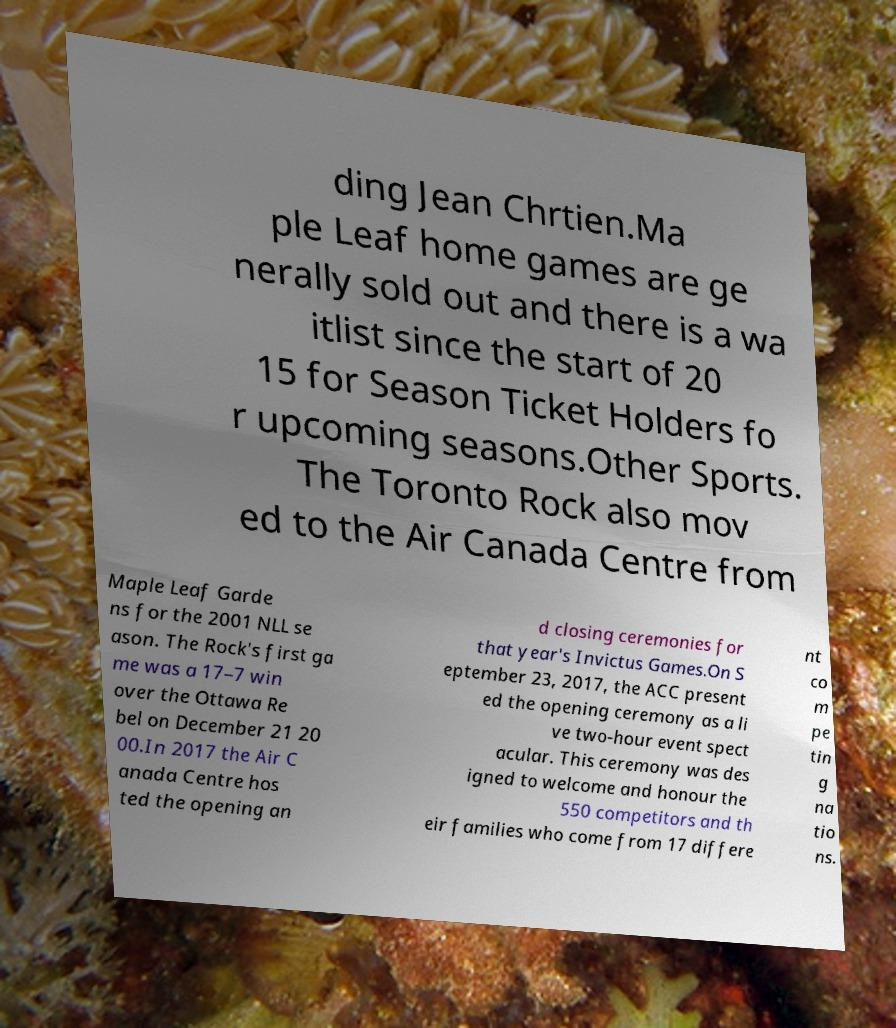Can you accurately transcribe the text from the provided image for me? ding Jean Chrtien.Ma ple Leaf home games are ge nerally sold out and there is a wa itlist since the start of 20 15 for Season Ticket Holders fo r upcoming seasons.Other Sports. The Toronto Rock also mov ed to the Air Canada Centre from Maple Leaf Garde ns for the 2001 NLL se ason. The Rock's first ga me was a 17–7 win over the Ottawa Re bel on December 21 20 00.In 2017 the Air C anada Centre hos ted the opening an d closing ceremonies for that year's Invictus Games.On S eptember 23, 2017, the ACC present ed the opening ceremony as a li ve two-hour event spect acular. This ceremony was des igned to welcome and honour the 550 competitors and th eir families who come from 17 differe nt co m pe tin g na tio ns. 